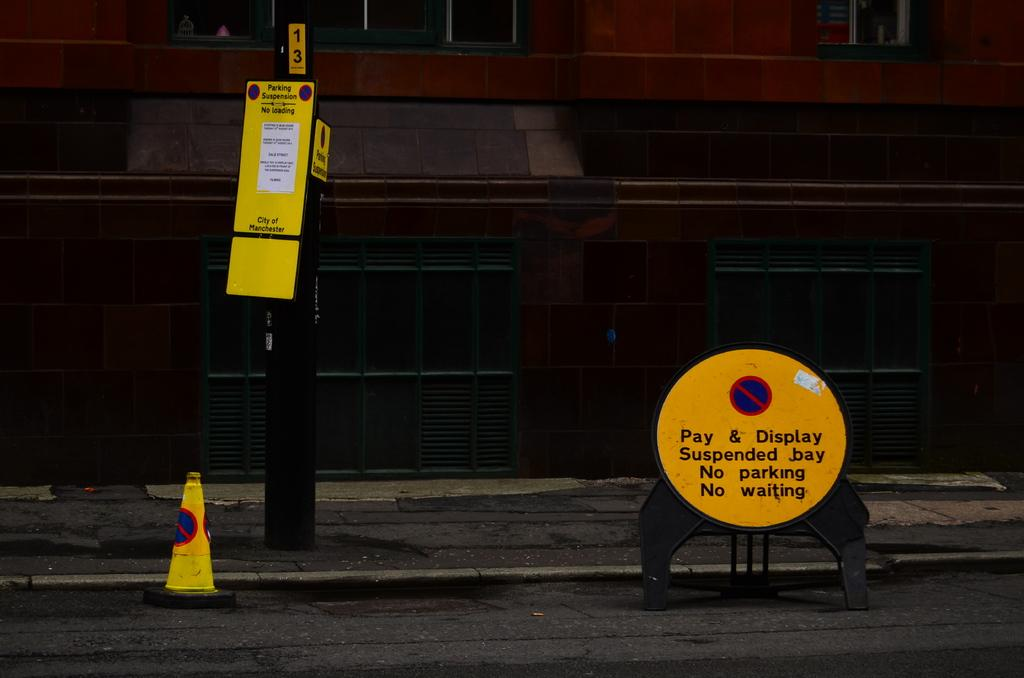Provide a one-sentence caption for the provided image. A buliding with a streetside that has warning signs that say there is a parking suspension - no parking, no waiting, no loading. 